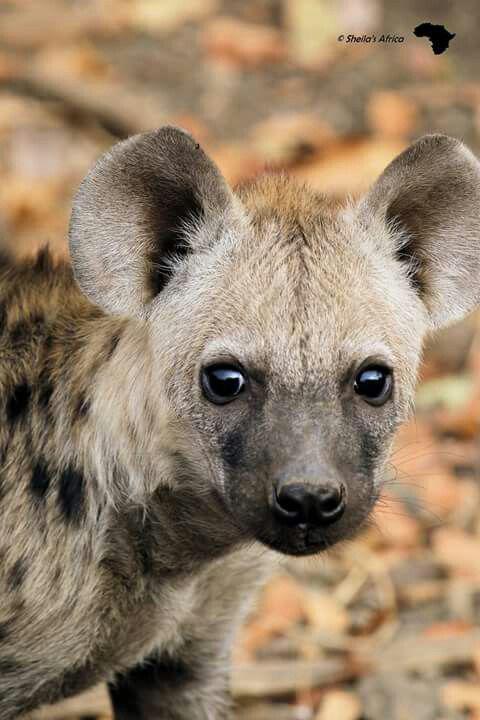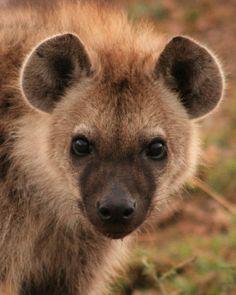The first image is the image on the left, the second image is the image on the right. Evaluate the accuracy of this statement regarding the images: "The body of the hyena on the left image is facing left". Is it true? Answer yes or no. No. 